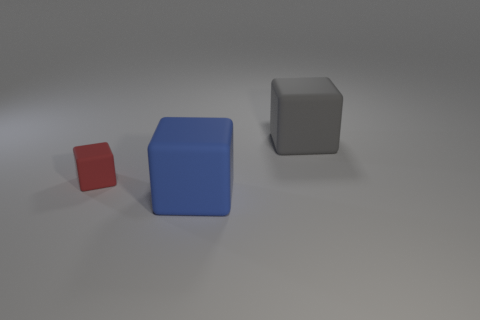Add 1 blue shiny spheres. How many objects exist? 4 Add 2 brown cylinders. How many brown cylinders exist? 2 Subtract 0 purple blocks. How many objects are left? 3 Subtract all blue rubber cylinders. Subtract all large gray matte objects. How many objects are left? 2 Add 3 big rubber blocks. How many big rubber blocks are left? 5 